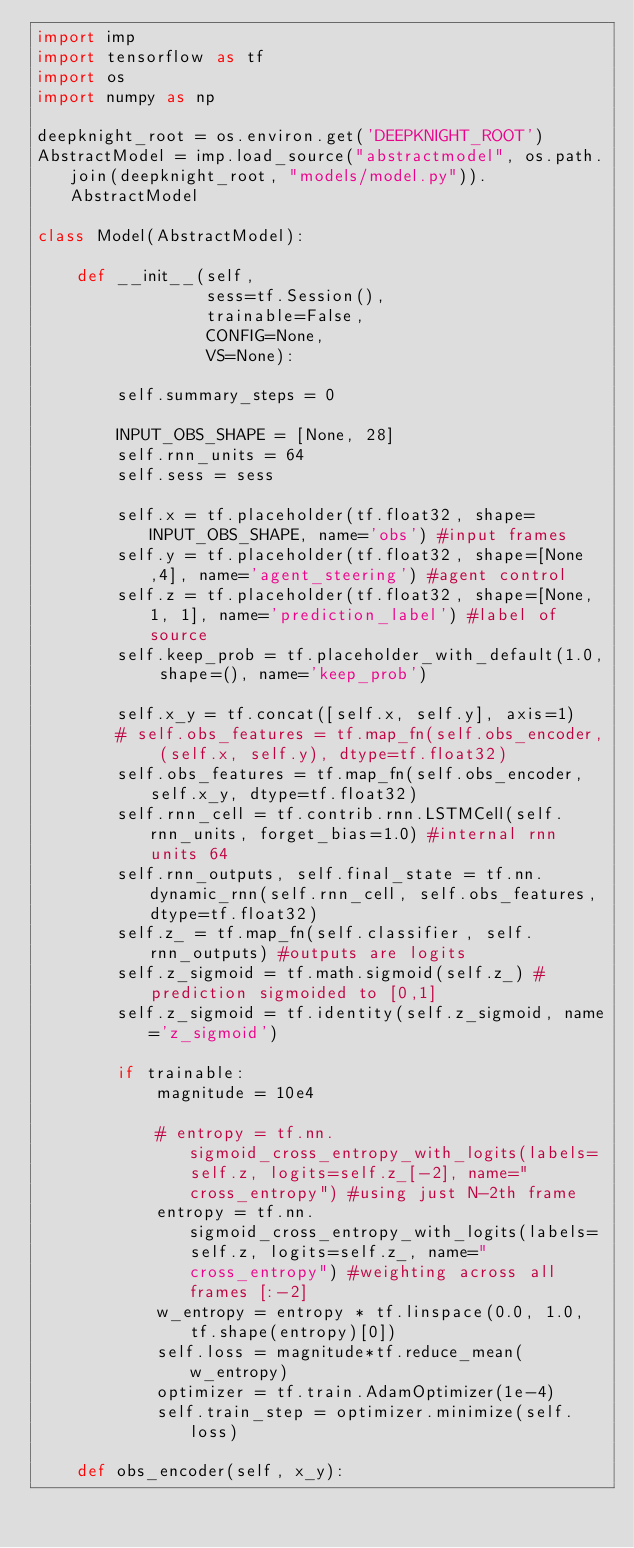<code> <loc_0><loc_0><loc_500><loc_500><_Python_>import imp
import tensorflow as tf
import os
import numpy as np

deepknight_root = os.environ.get('DEEPKNIGHT_ROOT')
AbstractModel = imp.load_source("abstractmodel", os.path.join(deepknight_root, "models/model.py")).AbstractModel

class Model(AbstractModel):

    def __init__(self,
                 sess=tf.Session(),
                 trainable=False,
                 CONFIG=None,
                 VS=None):

        self.summary_steps = 0

        INPUT_OBS_SHAPE = [None, 28]
        self.rnn_units = 64
        self.sess = sess

        self.x = tf.placeholder(tf.float32, shape=INPUT_OBS_SHAPE, name='obs') #input frames
        self.y = tf.placeholder(tf.float32, shape=[None,4], name='agent_steering') #agent control
        self.z = tf.placeholder(tf.float32, shape=[None, 1, 1], name='prediction_label') #label of source
        self.keep_prob = tf.placeholder_with_default(1.0, shape=(), name='keep_prob')

        self.x_y = tf.concat([self.x, self.y], axis=1)
        # self.obs_features = tf.map_fn(self.obs_encoder, (self.x, self.y), dtype=tf.float32)
        self.obs_features = tf.map_fn(self.obs_encoder, self.x_y, dtype=tf.float32)
        self.rnn_cell = tf.contrib.rnn.LSTMCell(self.rnn_units, forget_bias=1.0) #internal rnn units 64
        self.rnn_outputs, self.final_state = tf.nn.dynamic_rnn(self.rnn_cell, self.obs_features, dtype=tf.float32)
        self.z_ = tf.map_fn(self.classifier, self.rnn_outputs) #outputs are logits
        self.z_sigmoid = tf.math.sigmoid(self.z_) #prediction sigmoided to [0,1]
        self.z_sigmoid = tf.identity(self.z_sigmoid, name='z_sigmoid')

        if trainable:
            magnitude = 10e4

            # entropy = tf.nn.sigmoid_cross_entropy_with_logits(labels=self.z, logits=self.z_[-2], name="cross_entropy") #using just N-2th frame
            entropy = tf.nn.sigmoid_cross_entropy_with_logits(labels=self.z, logits=self.z_, name="cross_entropy") #weighting across all frames [:-2]
            w_entropy = entropy * tf.linspace(0.0, 1.0, tf.shape(entropy)[0])
            self.loss = magnitude*tf.reduce_mean(w_entropy)
            optimizer = tf.train.AdamOptimizer(1e-4)
            self.train_step = optimizer.minimize(self.loss)

    def obs_encoder(self, x_y):</code> 